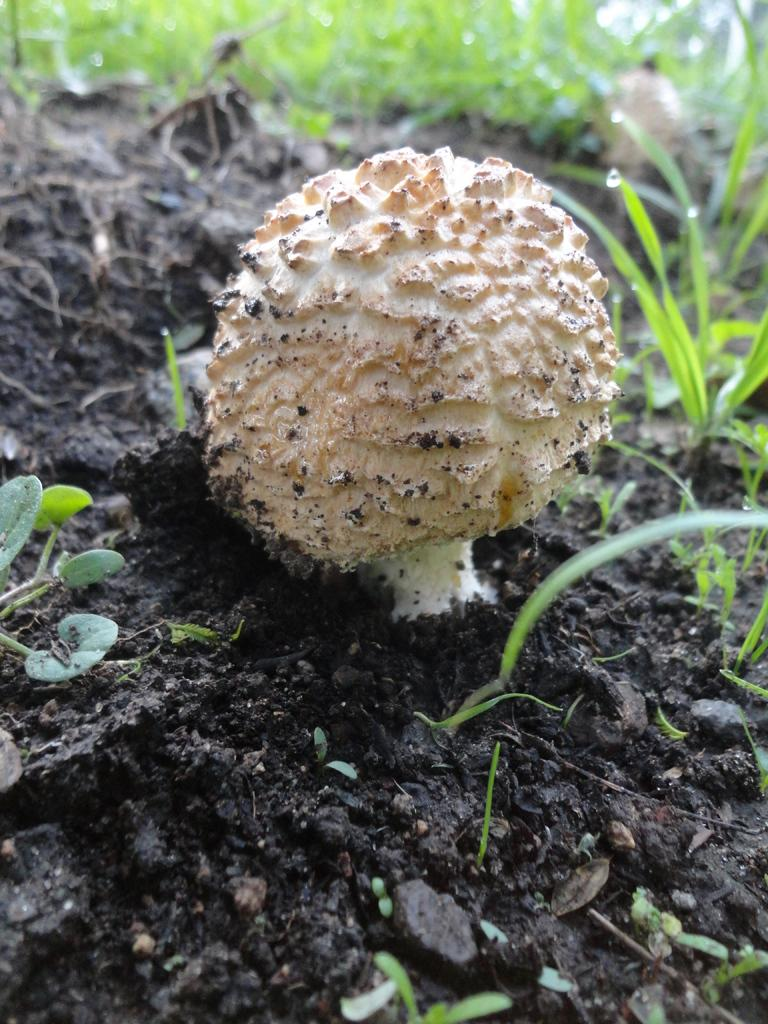What is the main subject of the image? The main subject of the image is a mushroom. Where is the mushroom located? The mushroom is on the land. What type of vegetation is visible behind the mushroom? There is grass behind the mushroom. What type of experience does the mushroom have with writing in the image? The mushroom does not have any experience with writing, as it is an inanimate object and cannot engage in such activities. 